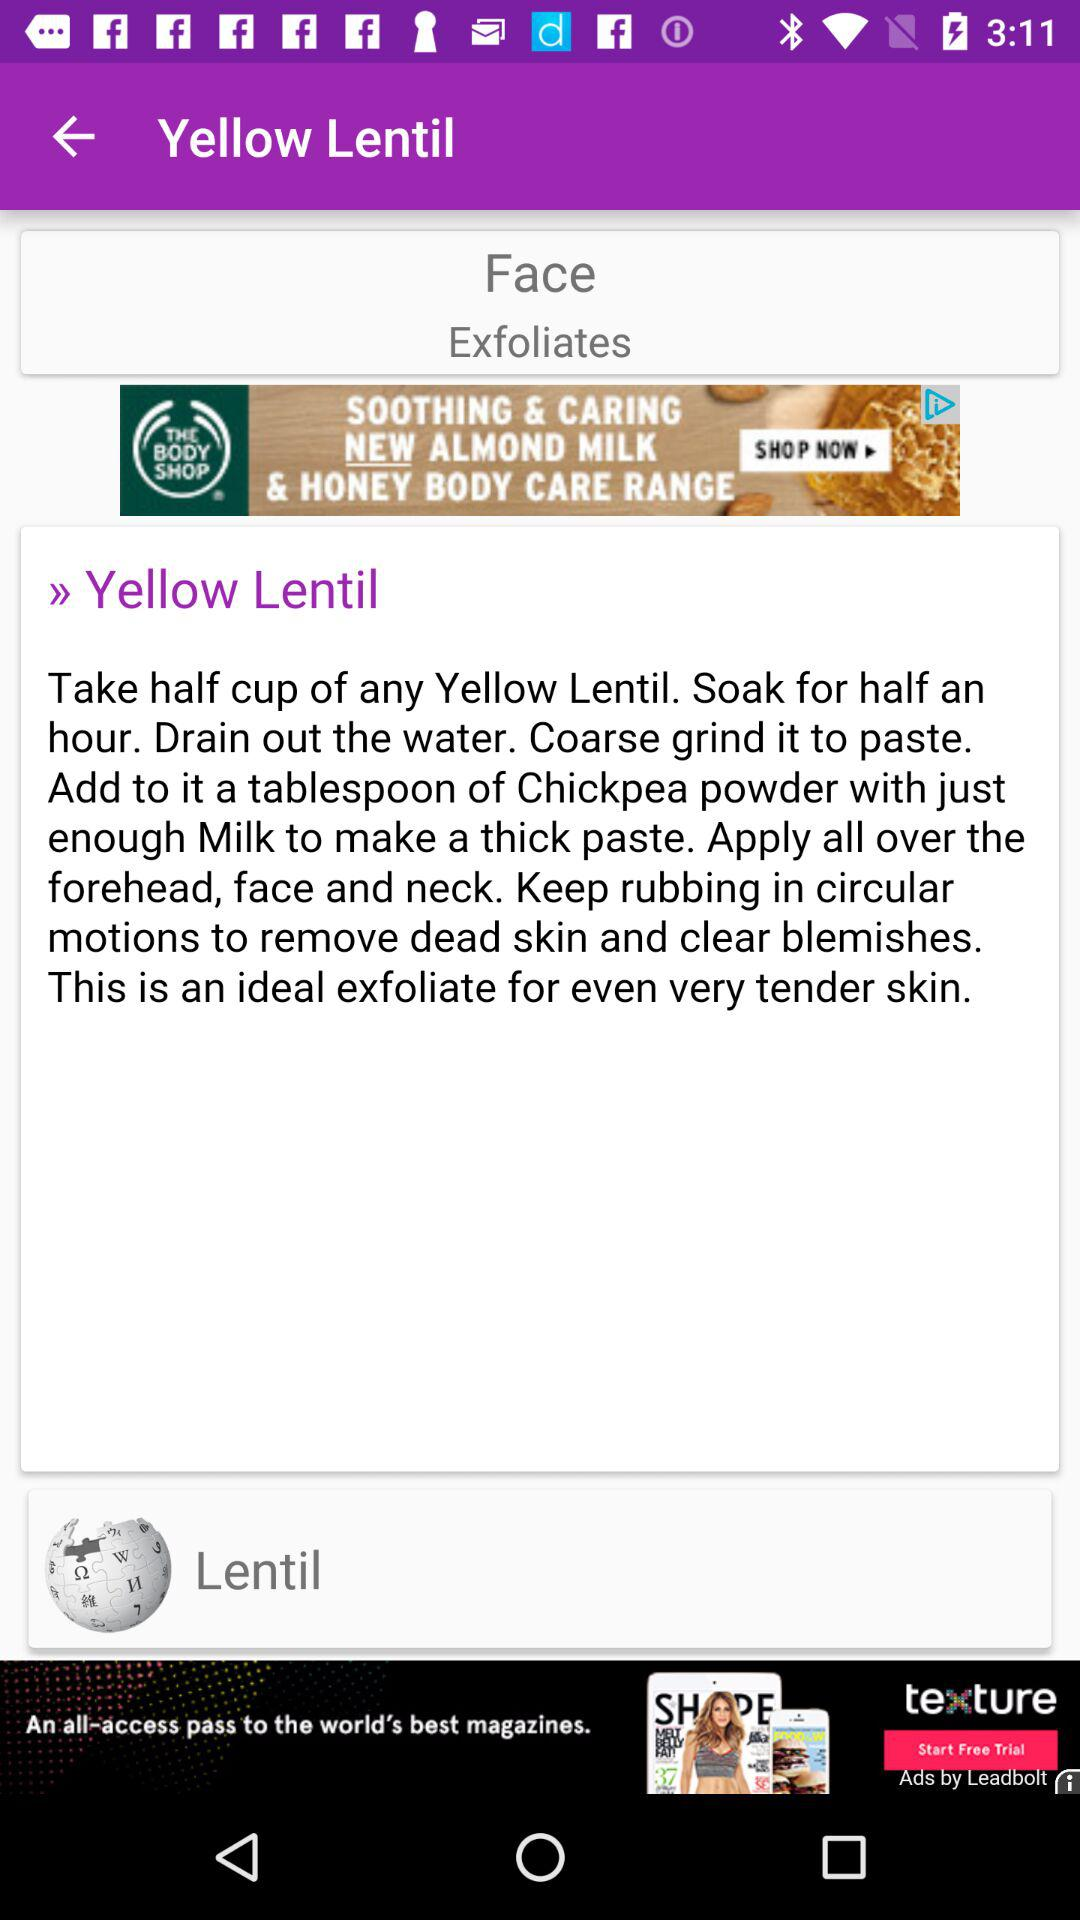What is the quantity required of yellow lentil? The required quantity is half a cup. 